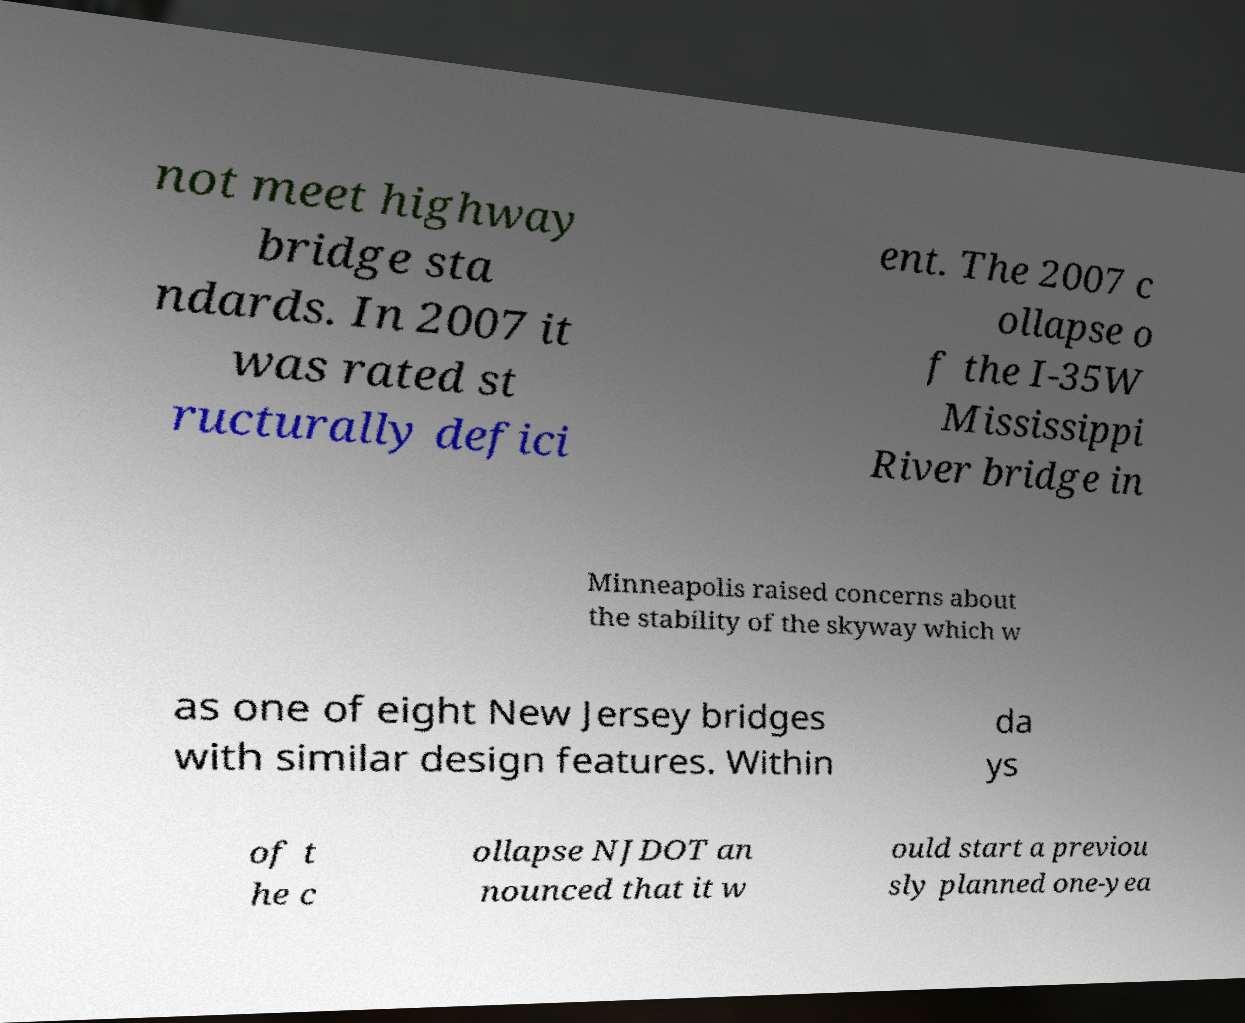Could you assist in decoding the text presented in this image and type it out clearly? not meet highway bridge sta ndards. In 2007 it was rated st ructurally defici ent. The 2007 c ollapse o f the I-35W Mississippi River bridge in Minneapolis raised concerns about the stability of the skyway which w as one of eight New Jersey bridges with similar design features. Within da ys of t he c ollapse NJDOT an nounced that it w ould start a previou sly planned one-yea 